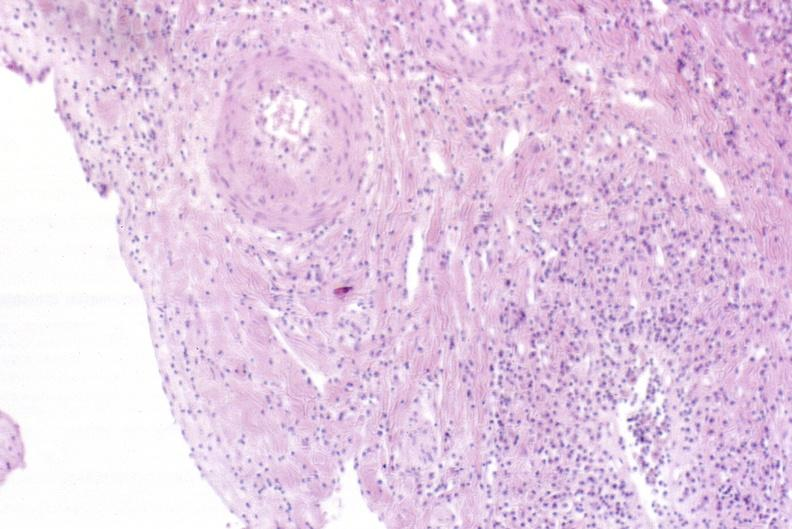what does this image show?
Answer the question using a single word or phrase. Severe acute rejection 